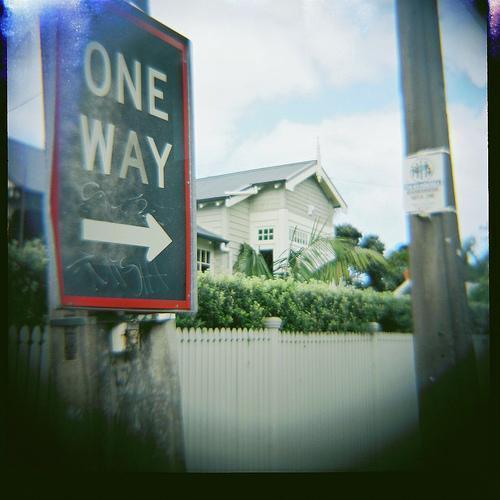How many poles are there?
Give a very brief answer. 2. 